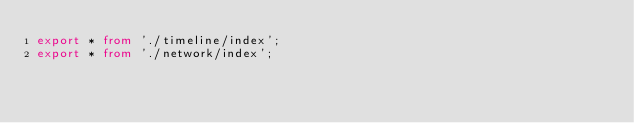Convert code to text. <code><loc_0><loc_0><loc_500><loc_500><_TypeScript_>export * from './timeline/index';
export * from './network/index';
</code> 